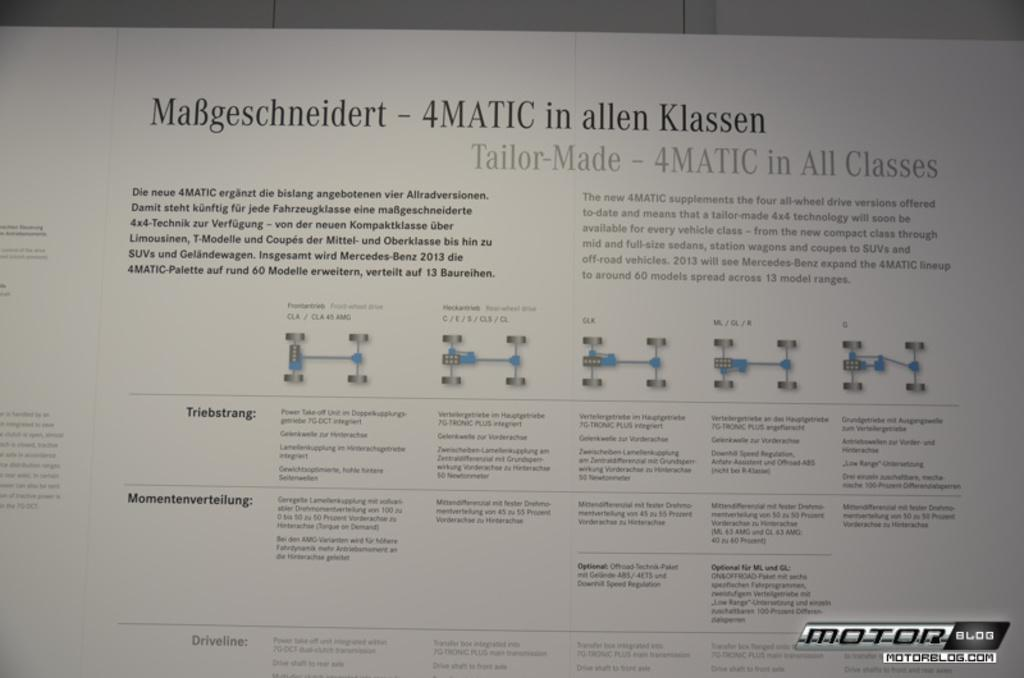Provide a one-sentence caption for the provided image. 4matic instructions and pictures page on motorblog.com site. 